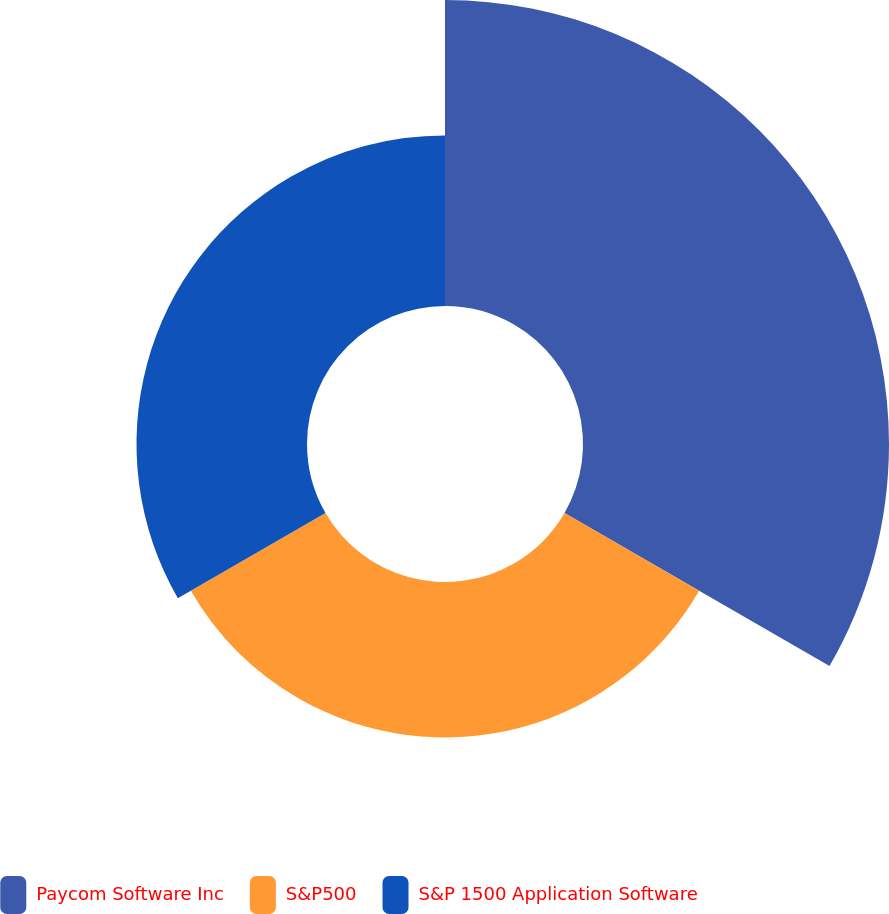Convert chart to OTSL. <chart><loc_0><loc_0><loc_500><loc_500><pie_chart><fcel>Paycom Software Inc<fcel>S&P500<fcel>S&P 1500 Application Software<nl><fcel>48.42%<fcel>24.6%<fcel>26.98%<nl></chart> 